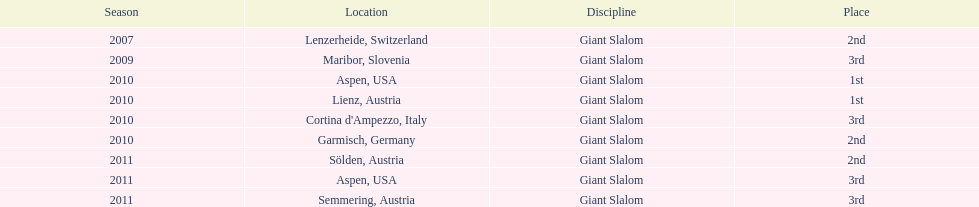Where was her first win? Aspen, USA. 